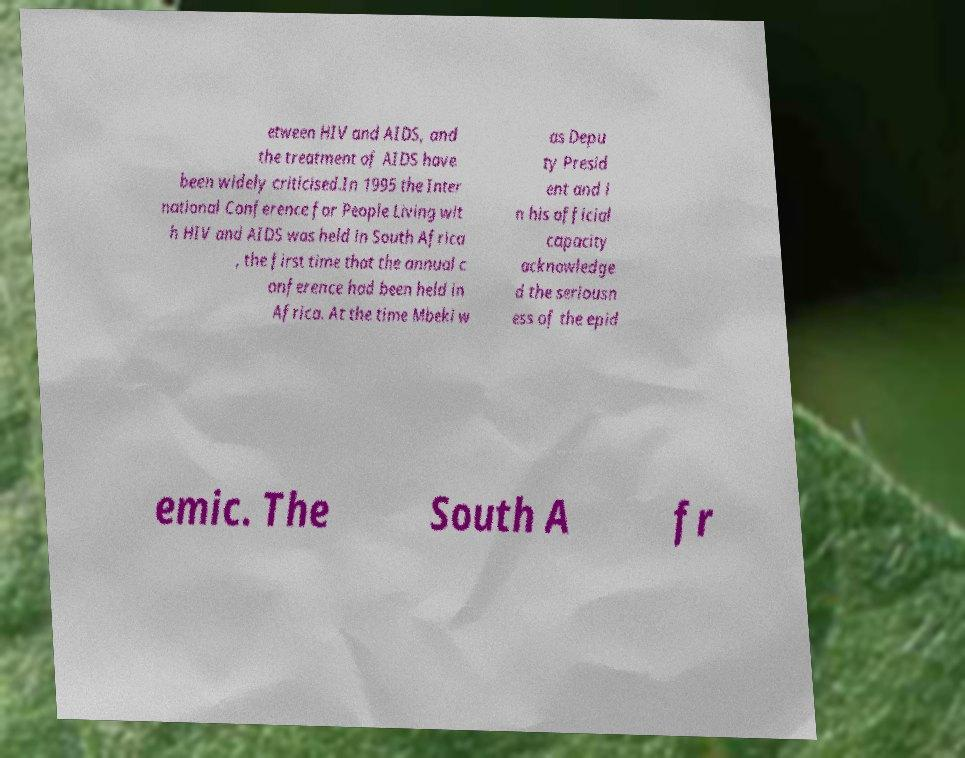For documentation purposes, I need the text within this image transcribed. Could you provide that? etween HIV and AIDS, and the treatment of AIDS have been widely criticised.In 1995 the Inter national Conference for People Living wit h HIV and AIDS was held in South Africa , the first time that the annual c onference had been held in Africa. At the time Mbeki w as Depu ty Presid ent and i n his official capacity acknowledge d the seriousn ess of the epid emic. The South A fr 